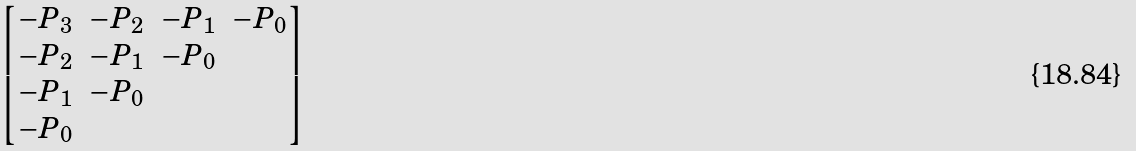Convert formula to latex. <formula><loc_0><loc_0><loc_500><loc_500>\begin{bmatrix} - P _ { 3 } & - P _ { 2 } & - P _ { 1 } & - P _ { 0 } \\ - P _ { 2 } & - P _ { 1 } & - P _ { 0 } & \\ - P _ { 1 } & - P _ { 0 } & & \\ - P _ { 0 } & & & \end{bmatrix}</formula> 